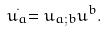Convert formula to latex. <formula><loc_0><loc_0><loc_500><loc_500>\stackrel { . } { u _ { a } } = u _ { a ; b } u ^ { b } .</formula> 